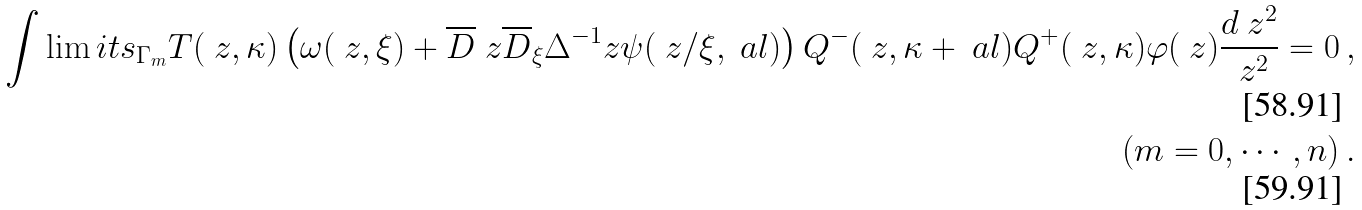Convert formula to latex. <formula><loc_0><loc_0><loc_500><loc_500>\int \lim i t s _ { \Gamma _ { m } } T ( \ z , \kappa ) \left ( \omega ( \ z , \xi ) + \overline { D } _ { \ } z \overline { D } _ { \xi } \Delta ^ { - 1 } _ { \ } z \psi ( \ z / \xi , \ a l ) \right ) Q ^ { - } ( \ z , \kappa + \ a l ) Q ^ { + } ( \ z , \kappa ) \varphi ( \ z ) \frac { d \ z ^ { 2 } } { \ z ^ { 2 } } = 0 \, , \\ \quad ( m = 0 , \cdots , n ) \, .</formula> 